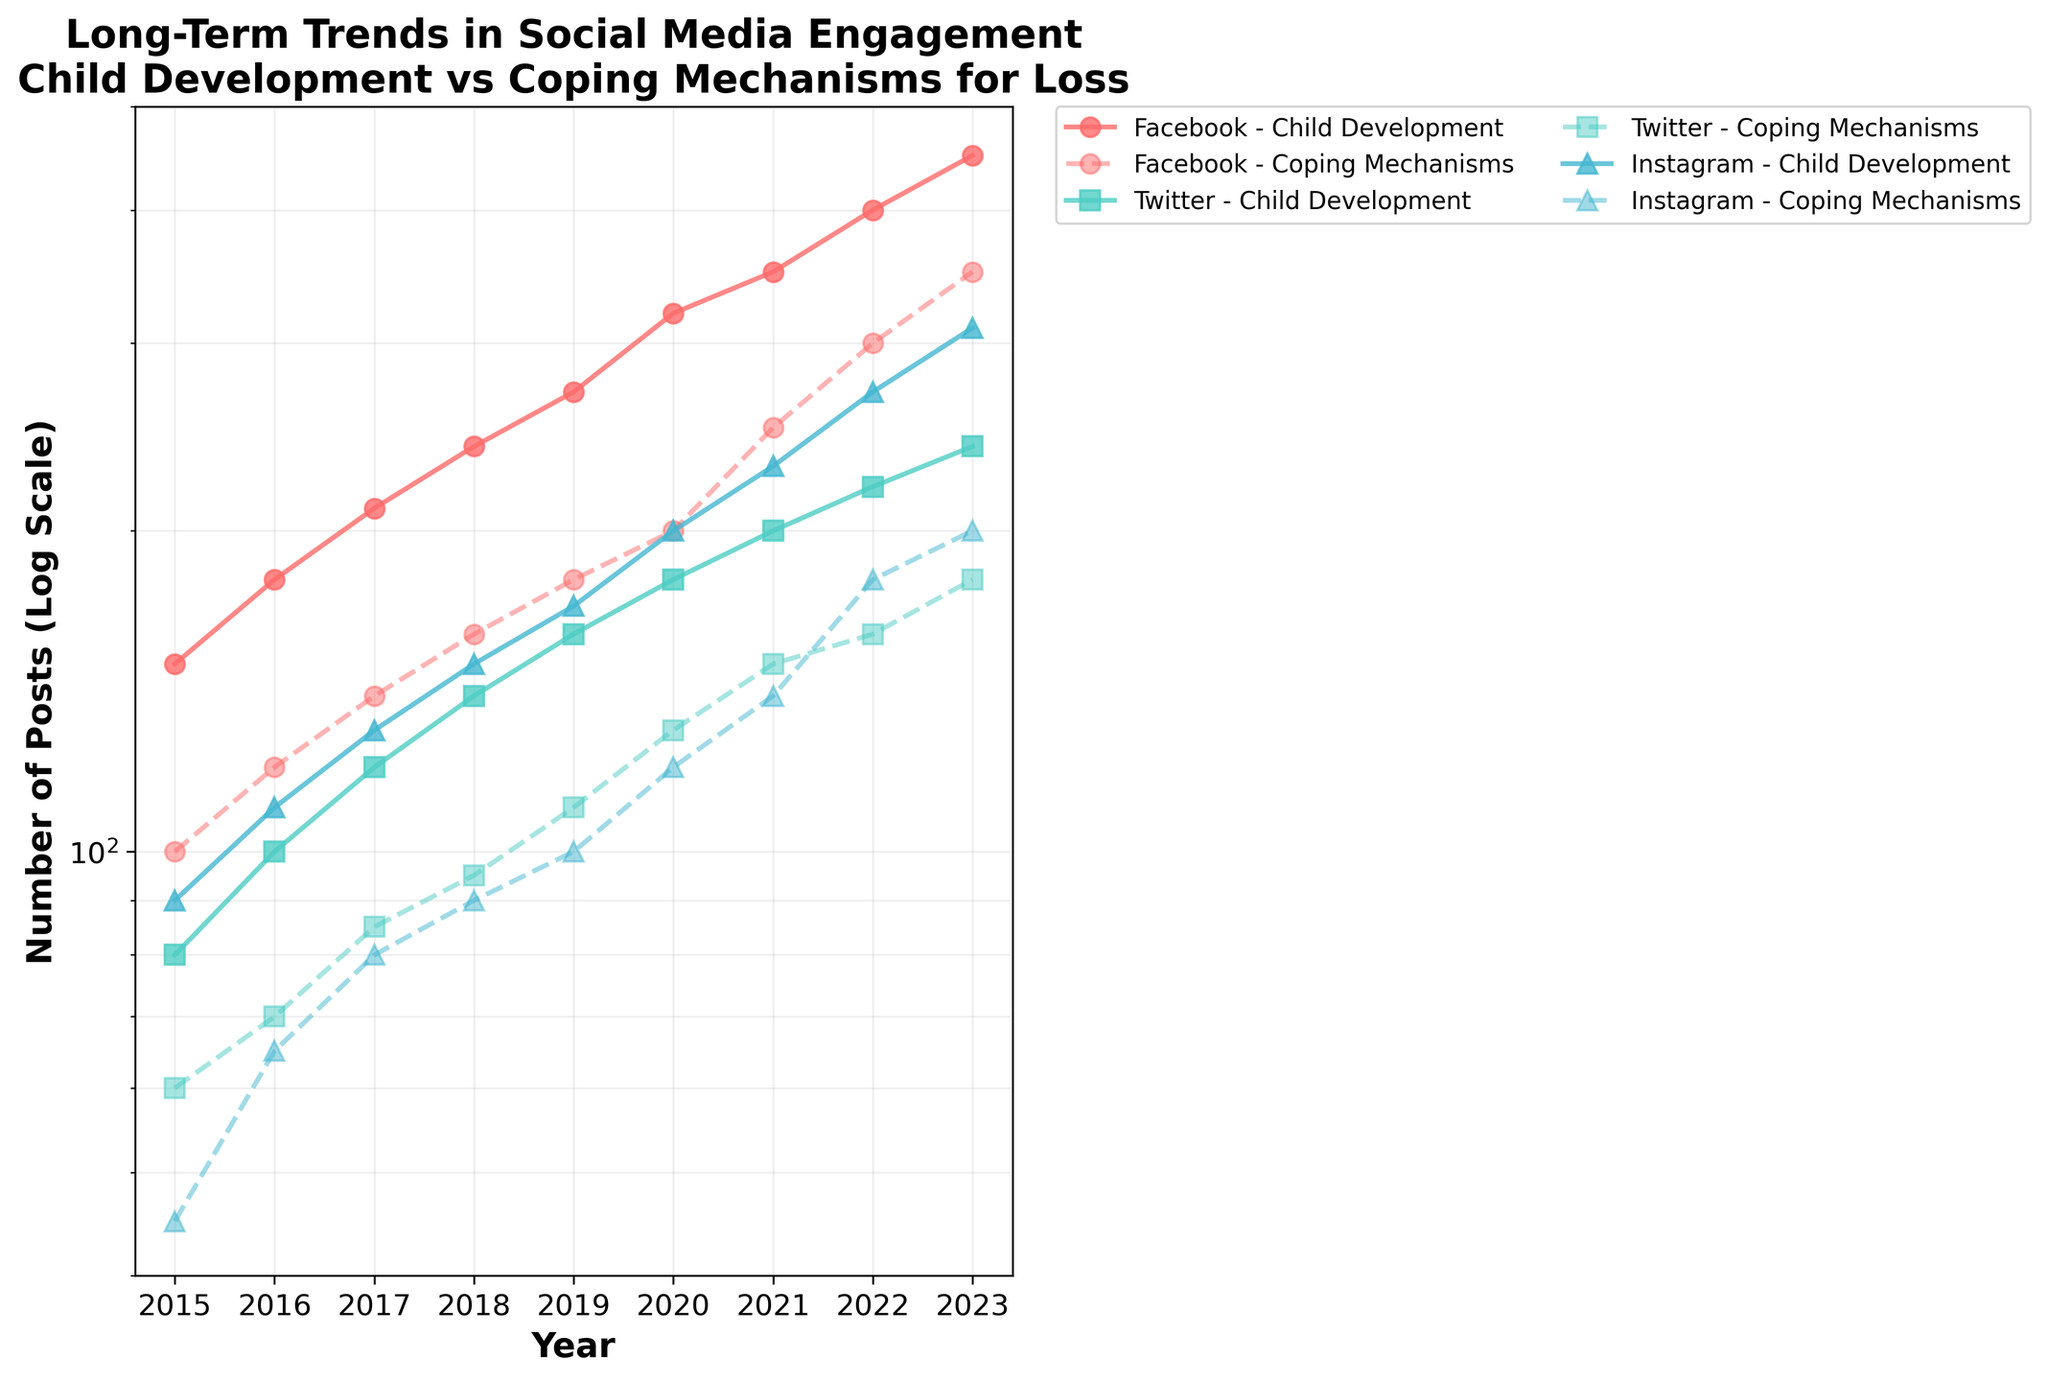What is the overall trend in posts on child development on Facebook from 2015 to 2023? The trend line for posts on child development on Facebook shows a steady increase from 150 posts in 2015 to 450 posts in 2023.
Answer: Steady increase Which social media platform had the highest number of posts on coping mechanisms for loss in 2023? According to the plot, Facebook had the highest number of posts on coping mechanisms for loss in 2023, with 350 posts.
Answer: Facebook Compare the number of posts on child development on Instagram in 2015 and 2023. How much has it increased by? In 2015, there were 90 posts on child development on Instagram. This number increased to 310 posts in 2023. The increase is 310 - 90 = 220 posts.
Answer: 220 posts What is the difference in the number of posts on coping mechanisms for loss between Twitter and Instagram in 2019? In 2019, Twitter had 110 posts on coping mechanisms for loss, while Instagram had 100 posts. The difference is 110 - 100 = 10 posts.
Answer: 10 posts How did the number of posts on coping mechanisms for loss on Twitter change from 2015 to 2020? The number of posts on coping mechanisms for loss on Twitter increased from 60 in 2015 to 130 in 2020. This shows a steady increase over the years.
Answer: Steady increase Which platform showed the greatest growth in posts on child development from 2015 to 2023? Facebook showed the greatest growth in posts on child development, increasing from 150 posts in 2015 to 450 posts in 2023.
Answer: Facebook On which platform and for which category did you observe the highest number of posts in the entire period? The highest number of posts observed in the entire period was for child development on Facebook, with 450 posts in 2023.
Answer: Facebook, child development When comparing posts on coping mechanisms for loss, which year saw the smallest difference between Instagram and Facebook? In 2018, the difference between Instagram (90 posts) and Facebook (160 posts) on coping mechanisms for loss was the smallest, which is 160 - 90 = 70 posts.
Answer: 2018 What can be said about the trend of posts on taking only the log-scaled y-axis into consideration? The log scale helps to better visualize the trend even with large differences in the number of posts. The trends for all platforms are generally increasing over time for both categories.
Answer: Increasing trends How does the trend of posts on child development on Twitter compare to that on Instagram from 2015 to 2023? Both Twitter and Instagram show an increasing trend for posts on child development, with Twitter increasing from 80 in 2015 to 240 in 2023, and Instagram from 90 in 2015 to 310 in 2023.
Answer: Both increasing 